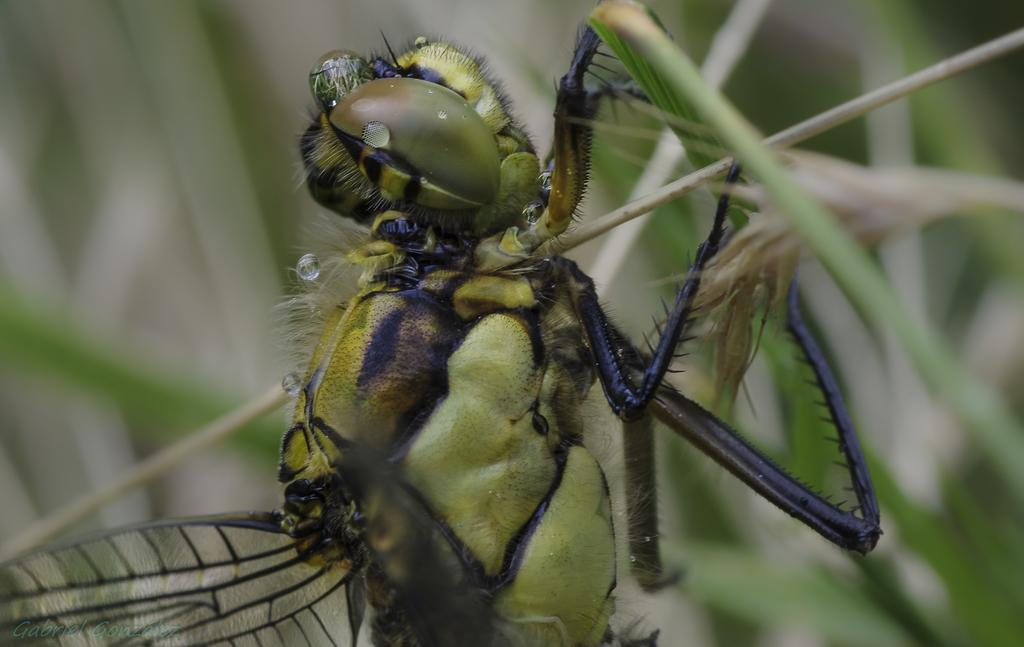What type of creature is in the picture? There is an insect in the picture. What is the color of the insect? The insect is green in color. What features does the insect have? The insect has eyes, legs, and wings. Where is the insect located in the picture? The insect is sitting on a plant. What type of church can be seen in the background of the image? There is no church present in the image; it features an insect sitting on a plant. 